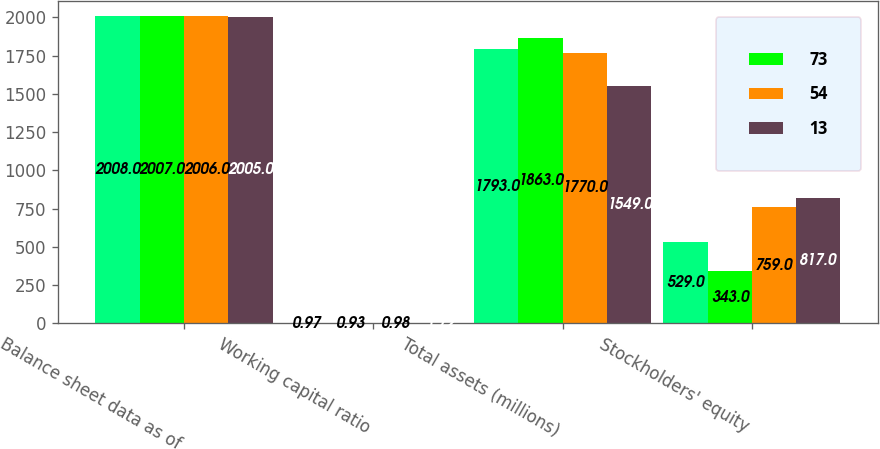<chart> <loc_0><loc_0><loc_500><loc_500><stacked_bar_chart><ecel><fcel>Balance sheet data as of<fcel>Working capital ratio<fcel>Total assets (millions)<fcel>Stockholders' equity<nl><fcel>nan<fcel>2008<fcel>0.97<fcel>1793<fcel>529<nl><fcel>73<fcel>2007<fcel>0.93<fcel>1863<fcel>343<nl><fcel>54<fcel>2006<fcel>0.98<fcel>1770<fcel>759<nl><fcel>13<fcel>2005<fcel>1.72<fcel>1549<fcel>817<nl></chart> 